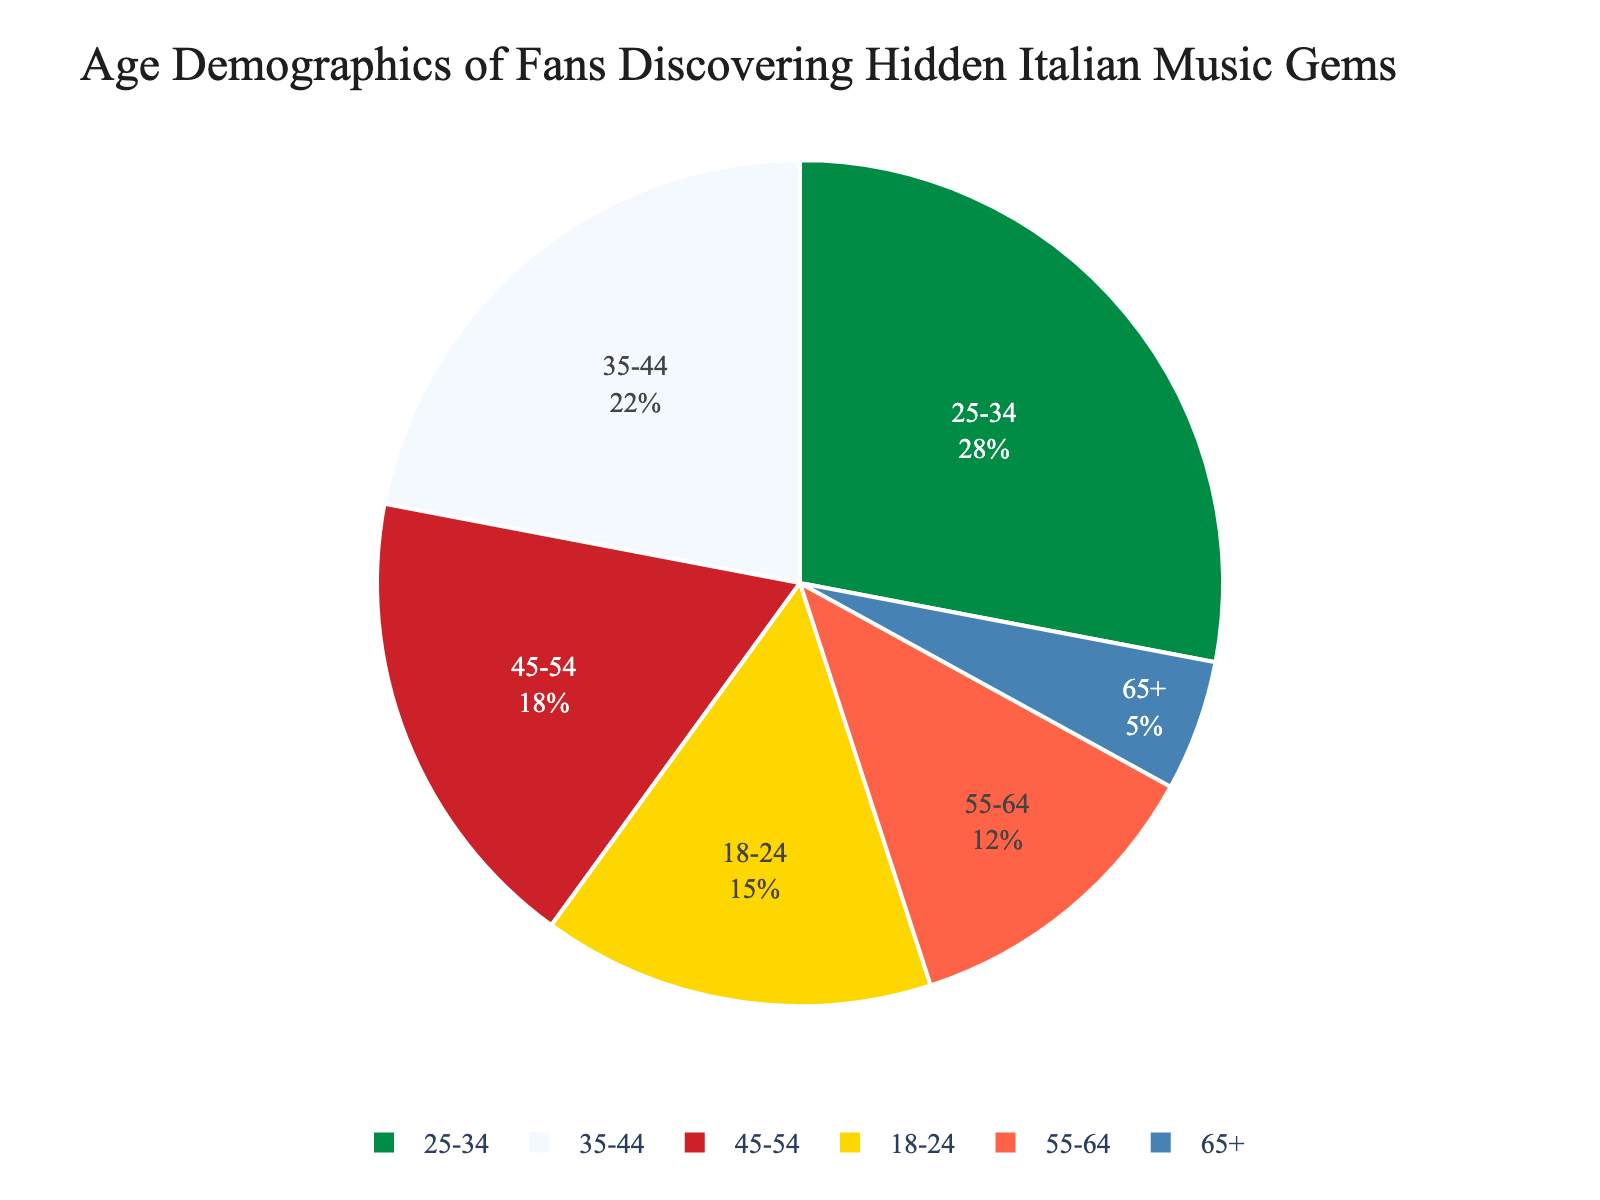Which age group has the highest percentage of fans discovering hidden Italian music gems? The pie chart shows the age group 25-34 with the largest segment, indicating they have the highest percentage.
Answer: 25-34 Which age group has the second-highest percentage of fans? The second largest segment in the pie chart belongs to the age group 35-44.
Answer: 35-44 What is the percentage difference between the age group 18-24 and 65+? The pie chart shows that 18-24 is 15% and 65+ is 5%. The difference is 15% - 5% = 10%.
Answer: 10% Is the percentage of fans aged 45-54 greater than or less than those aged 35-44? The pie chart shows 45-54 at 18% and 35-44 at 22%. Since 18% is less than 22%, the percentage for 45-54 is less.
Answer: Less Which two age groups combined have a percentage of exactly 30%? Looking at the pie chart, the age groups 55-64 (12%) and 18-24 (15%) together sum to 12% + 15% = 27%. However, the groups 65+ (5%) and 18-24 (15%) together sum to 20%. The only pair adding up to 30% are ages 18-24 (15%) and 45-54 (18%), combining to 33%.
Answer: None What is the combined percentage of age groups under 35? Adding the percentages for 18-24 (15%) and 25-34 (28%) gives 15% + 28% = 43%.
Answer: 43% How does the fan percentage for ages 55-64 compare to that for 45-54? The age group 55-64 is 12% and the group 45-54 is 18%. Comparing them, 12% is less than 18%.
Answer: Less What age group has a smaller fan percentage than the age group 35-44 but higher than the age group 55-64? The age group 45-54 with 18% fits this criteria as it’s smaller than 35-44 (22%) but higher than 55-64 (12%).
Answer: 45-54 Which color represents the age group 65+ on the pie chart? The color section corresponding to the age group 65+ is the smallest segment, often colored to stand out distinctly from larger segments, and tends to appear by itself. It's most likely the blue segment at the lower part of the chart.
Answer: Blue 